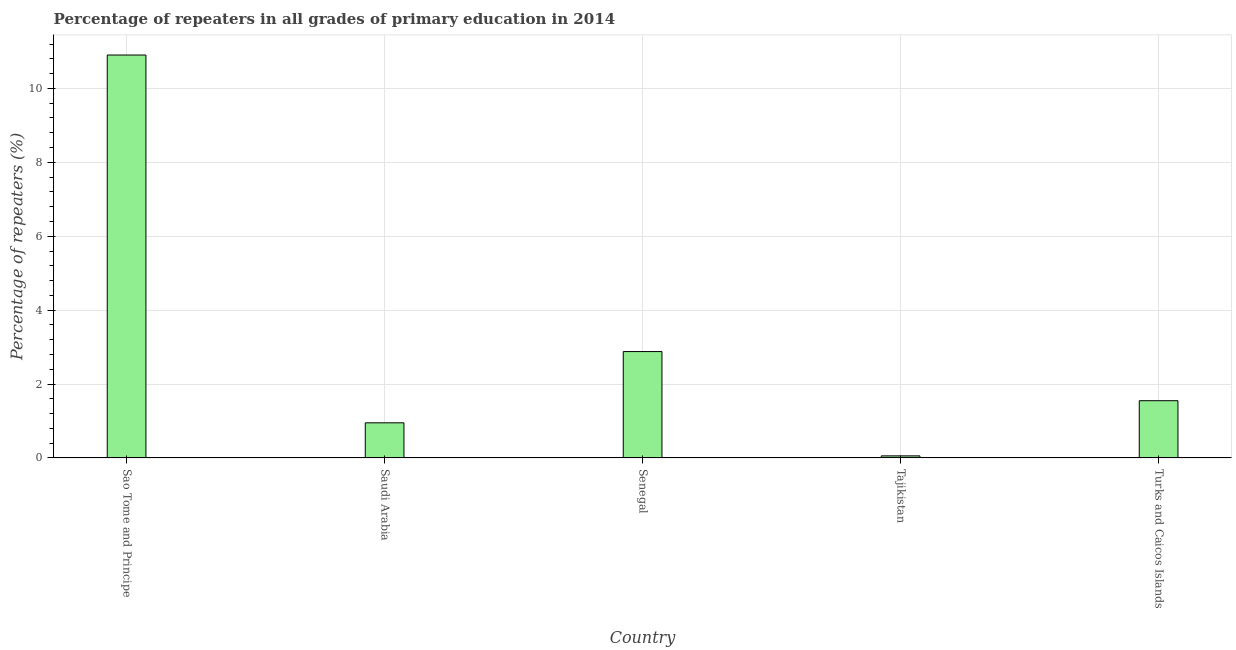Does the graph contain any zero values?
Your answer should be very brief. No. Does the graph contain grids?
Keep it short and to the point. Yes. What is the title of the graph?
Give a very brief answer. Percentage of repeaters in all grades of primary education in 2014. What is the label or title of the X-axis?
Provide a succinct answer. Country. What is the label or title of the Y-axis?
Provide a succinct answer. Percentage of repeaters (%). What is the percentage of repeaters in primary education in Turks and Caicos Islands?
Offer a very short reply. 1.55. Across all countries, what is the maximum percentage of repeaters in primary education?
Make the answer very short. 10.9. Across all countries, what is the minimum percentage of repeaters in primary education?
Provide a short and direct response. 0.06. In which country was the percentage of repeaters in primary education maximum?
Provide a short and direct response. Sao Tome and Principe. In which country was the percentage of repeaters in primary education minimum?
Offer a very short reply. Tajikistan. What is the sum of the percentage of repeaters in primary education?
Give a very brief answer. 16.34. What is the difference between the percentage of repeaters in primary education in Tajikistan and Turks and Caicos Islands?
Provide a short and direct response. -1.49. What is the average percentage of repeaters in primary education per country?
Keep it short and to the point. 3.27. What is the median percentage of repeaters in primary education?
Your response must be concise. 1.55. What is the ratio of the percentage of repeaters in primary education in Sao Tome and Principe to that in Saudi Arabia?
Ensure brevity in your answer.  11.47. Is the percentage of repeaters in primary education in Saudi Arabia less than that in Turks and Caicos Islands?
Your answer should be compact. Yes. Is the difference between the percentage of repeaters in primary education in Sao Tome and Principe and Tajikistan greater than the difference between any two countries?
Your response must be concise. Yes. What is the difference between the highest and the second highest percentage of repeaters in primary education?
Your answer should be very brief. 8.03. What is the difference between the highest and the lowest percentage of repeaters in primary education?
Provide a succinct answer. 10.85. Are all the bars in the graph horizontal?
Your answer should be very brief. No. How many countries are there in the graph?
Give a very brief answer. 5. What is the difference between two consecutive major ticks on the Y-axis?
Ensure brevity in your answer.  2. What is the Percentage of repeaters (%) in Sao Tome and Principe?
Offer a very short reply. 10.9. What is the Percentage of repeaters (%) in Saudi Arabia?
Offer a very short reply. 0.95. What is the Percentage of repeaters (%) in Senegal?
Make the answer very short. 2.88. What is the Percentage of repeaters (%) of Tajikistan?
Offer a very short reply. 0.06. What is the Percentage of repeaters (%) in Turks and Caicos Islands?
Your answer should be compact. 1.55. What is the difference between the Percentage of repeaters (%) in Sao Tome and Principe and Saudi Arabia?
Your answer should be very brief. 9.95. What is the difference between the Percentage of repeaters (%) in Sao Tome and Principe and Senegal?
Keep it short and to the point. 8.02. What is the difference between the Percentage of repeaters (%) in Sao Tome and Principe and Tajikistan?
Your answer should be very brief. 10.85. What is the difference between the Percentage of repeaters (%) in Sao Tome and Principe and Turks and Caicos Islands?
Your answer should be compact. 9.35. What is the difference between the Percentage of repeaters (%) in Saudi Arabia and Senegal?
Provide a short and direct response. -1.93. What is the difference between the Percentage of repeaters (%) in Saudi Arabia and Tajikistan?
Keep it short and to the point. 0.89. What is the difference between the Percentage of repeaters (%) in Saudi Arabia and Turks and Caicos Islands?
Offer a terse response. -0.6. What is the difference between the Percentage of repeaters (%) in Senegal and Tajikistan?
Provide a succinct answer. 2.82. What is the difference between the Percentage of repeaters (%) in Senegal and Turks and Caicos Islands?
Ensure brevity in your answer.  1.33. What is the difference between the Percentage of repeaters (%) in Tajikistan and Turks and Caicos Islands?
Offer a terse response. -1.49. What is the ratio of the Percentage of repeaters (%) in Sao Tome and Principe to that in Saudi Arabia?
Offer a terse response. 11.47. What is the ratio of the Percentage of repeaters (%) in Sao Tome and Principe to that in Senegal?
Ensure brevity in your answer.  3.79. What is the ratio of the Percentage of repeaters (%) in Sao Tome and Principe to that in Tajikistan?
Offer a terse response. 194.67. What is the ratio of the Percentage of repeaters (%) in Sao Tome and Principe to that in Turks and Caicos Islands?
Your answer should be compact. 7.04. What is the ratio of the Percentage of repeaters (%) in Saudi Arabia to that in Senegal?
Your response must be concise. 0.33. What is the ratio of the Percentage of repeaters (%) in Saudi Arabia to that in Tajikistan?
Your answer should be compact. 16.97. What is the ratio of the Percentage of repeaters (%) in Saudi Arabia to that in Turks and Caicos Islands?
Offer a terse response. 0.61. What is the ratio of the Percentage of repeaters (%) in Senegal to that in Tajikistan?
Offer a very short reply. 51.39. What is the ratio of the Percentage of repeaters (%) in Senegal to that in Turks and Caicos Islands?
Your answer should be compact. 1.86. What is the ratio of the Percentage of repeaters (%) in Tajikistan to that in Turks and Caicos Islands?
Keep it short and to the point. 0.04. 